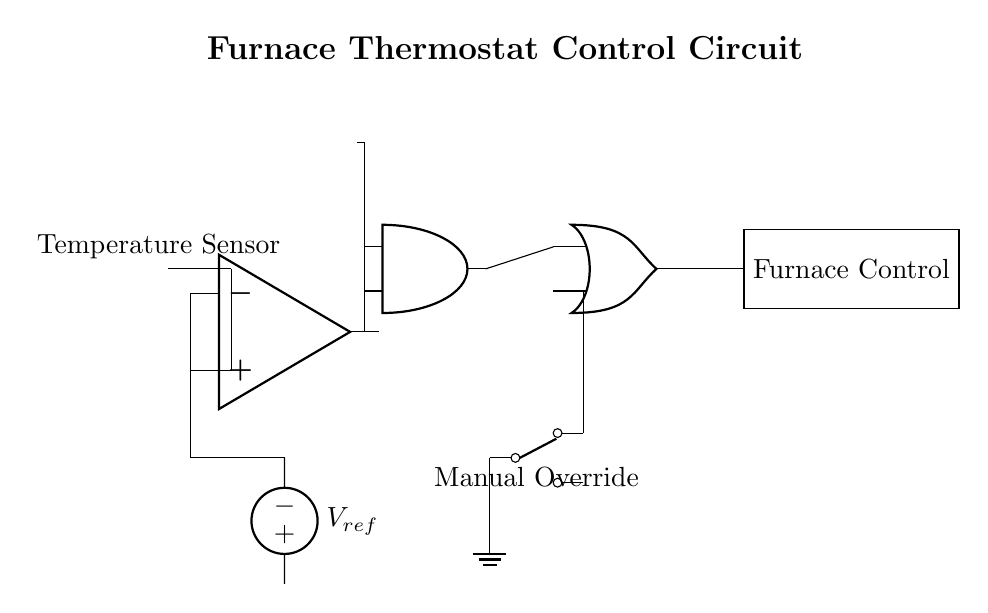What is the main purpose of this circuit? The main purpose of this circuit is to regulate the temperature of a furnace based on the input from a temperature sensor and settings from manual overrides.
Answer: Temperature regulation What type of sensor is used in this circuit? The circuit uses a thermistor, which is a type of temperature sensor that changes resistance with temperature.
Answer: Thermistor How many logic gates are present in the circuit? There are two logic gates in the circuit: one AND gate and one OR gate.
Answer: Two What component provides a reference voltage? The component that provides a reference voltage is labeled as V_ref, which is connected to the comparator.
Answer: V_ref What happens when the manual override switch is activated? When the manual override switch is activated, it allows the user to control the furnace regardless of the thermostat setting, by sending a signal to the OR gate.
Answer: It allows manual control Which component is indicated as the furnace control? The component labeled "Furnace Control" is a rectangle in the diagram that represents the main operation unit of the furnace.
Answer: Furnace Control What input does the AND gate require to function? The AND gate requires two inputs: one from the comparator's output and another from a timer voltage source, indicating both conditions must be met.
Answer: Comparator output and Timer 